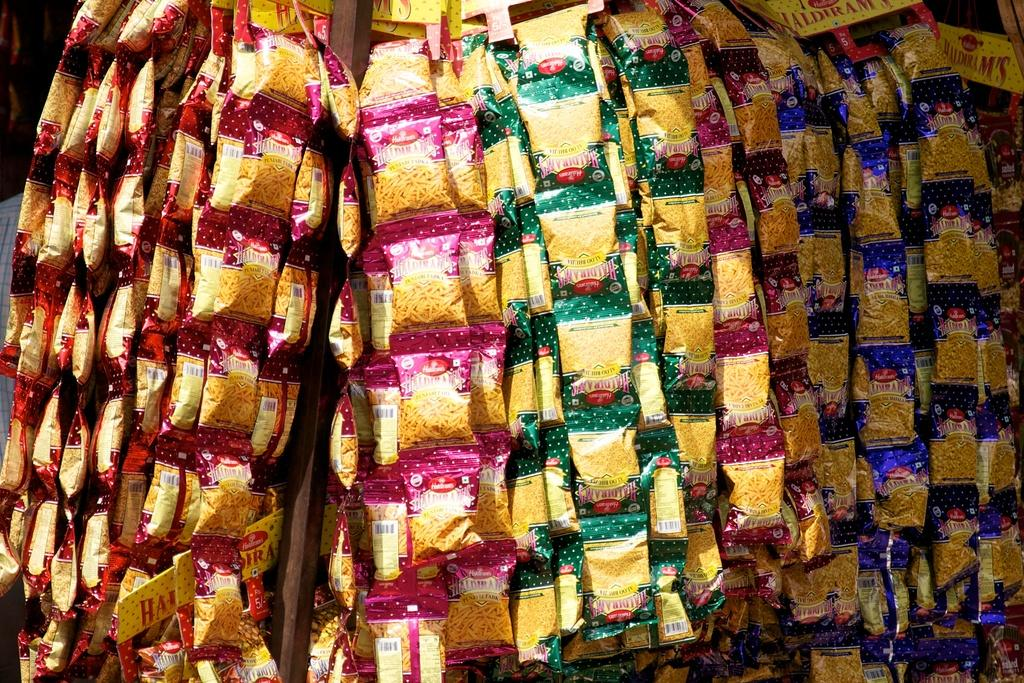What is hanging in the image? There are packets hanging in the image. What colors can be seen on the packets? The packets have pink, green, and blue colors. How many people are participating in the feast in the image? There is no feast or people present in the image; it only shows packets hanging with colors. 